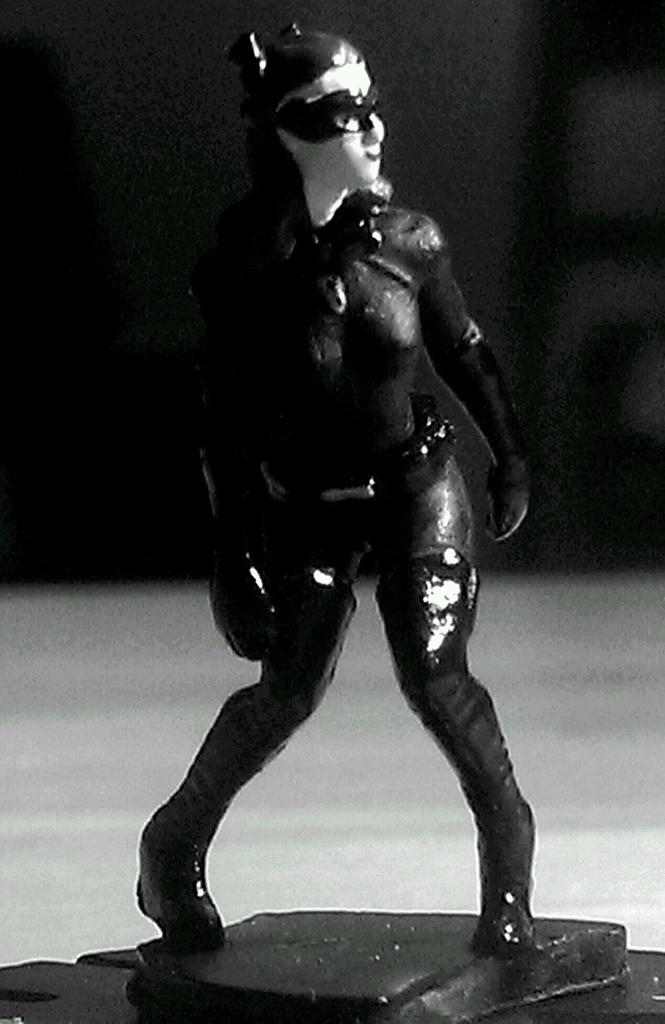What is the main subject of the image? There is a black color woman toy in the image. What is the toy placed on? The toy is on a white surface. How would you describe the overall appearance of the image? The background of the image is dark. What news is the woman toy reading in the image? There is no news or reading material present in the image; it only features a toy on a white surface. 